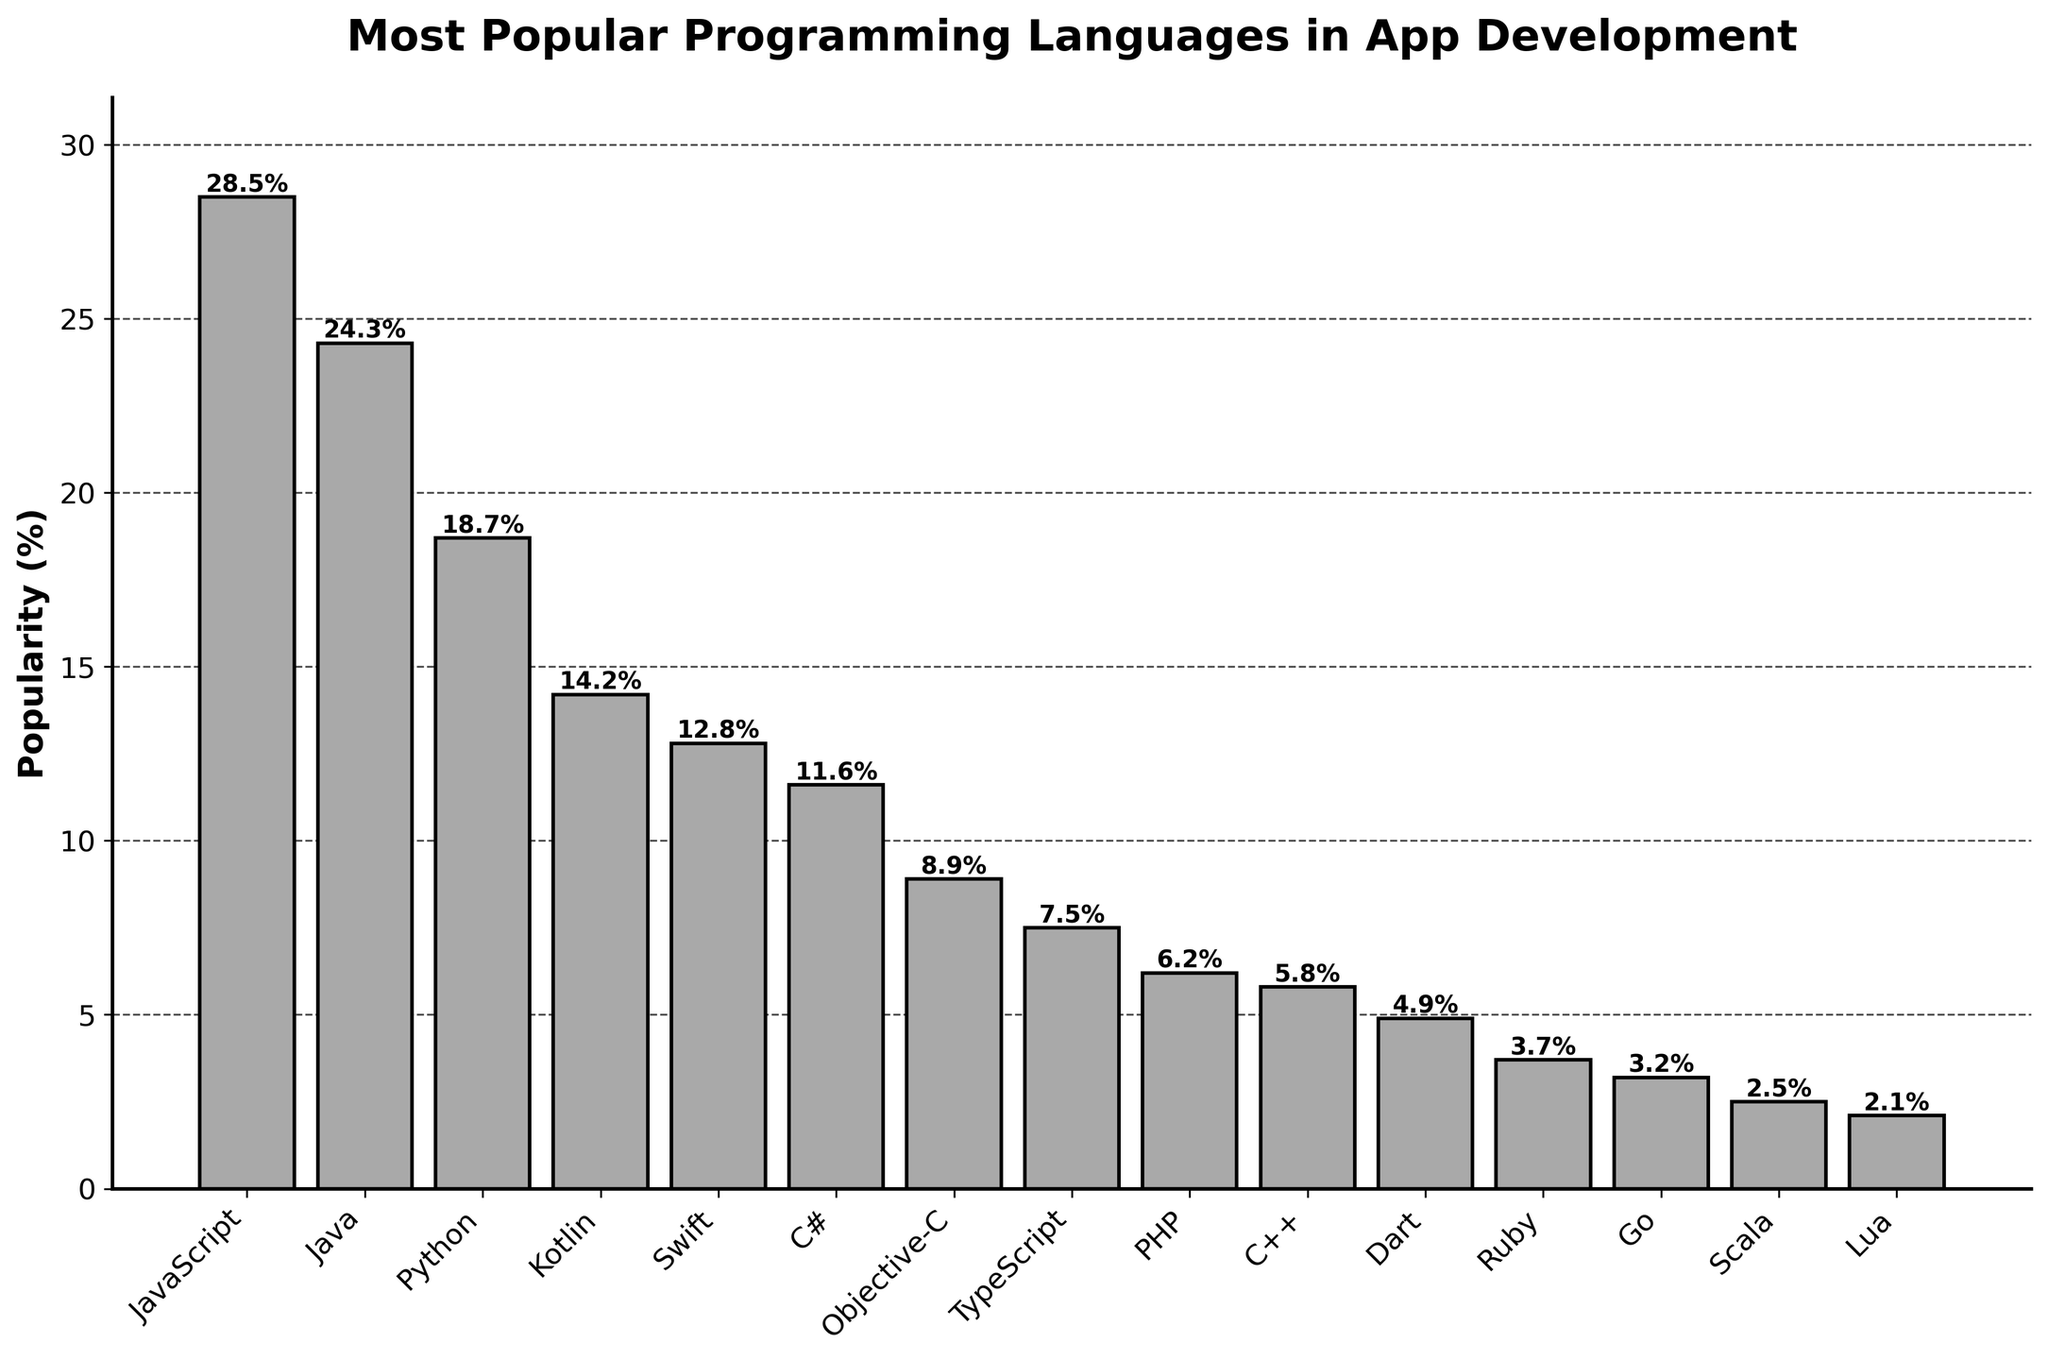Which programming language is the most popular for app development? Look at the bar with the highest value on the chart to identify the most popular programming language.
Answer: JavaScript Which language is more popular for app development, Python or Swift? Compare the heights of the bars for Python and Swift. The bar for Python is higher than Swift.
Answer: Python What is the total popularity percentage of JavaScript, Java, and Python? Sum the popularity percentages of JavaScript (28.5%), Java (24.3%), and Python (18.7%): 28.5 + 24.3 + 18.7 = 71.5.
Answer: 71.5% What is the difference in popularity between Kotlin and C#? Subtract the popularity percentage of C# (11.6%) from Kotlin (14.2%): 14.2 - 11.6 = 2.6.
Answer: 2.6% Which language has a lower popularity percentage, Dart or Ruby? Compare the bars for Dart and Ruby. The bar for Ruby (3.7%) is shorter than Dart (4.9%).
Answer: Ruby How many languages have a popularity percentage above 10%? Count all the bars with heights above 10%. JavaScript, Java, Python, Kotlin, and Swift each have a popularity percentage above 10%.
Answer: 5 What is the combined popularity percentage of the least popular three languages? Identify the three shortest bars' percentages: Scala (2.5%), Lua (2.1%), and Go (3.2%). Sum them: 2.5 + 2.1 + 3.2 = 7.8.
Answer: 7.8% Is TypeScript more popular than PHP in app development? Compare the heights of the bars for TypeScript and PHP. The bar for TypeScript (7.5%) is taller than PHP (6.2%).
Answer: Yes What is the average popularity percentage of JavaScript, Python, and C++? Sum their popularity percentages (28.5%, 18.7%, 5.8%) and divide by 3: (28.5 + 18.7 + 5.8) / 3 = 17.67.
Answer: 17.67% Are there more languages with a popularity percentage below or above 5%? Count the number of languages with bars above 5% and below 5%. Above 5%: 10 languages (JavaScript to C++), below 5%: 5 languages (Dart to Lua).
Answer: Above 